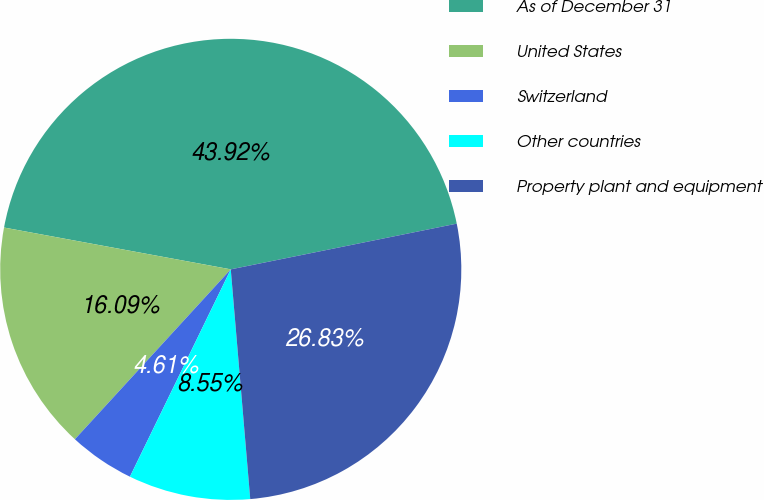Convert chart. <chart><loc_0><loc_0><loc_500><loc_500><pie_chart><fcel>As of December 31<fcel>United States<fcel>Switzerland<fcel>Other countries<fcel>Property plant and equipment<nl><fcel>43.92%<fcel>16.09%<fcel>4.61%<fcel>8.55%<fcel>26.83%<nl></chart> 